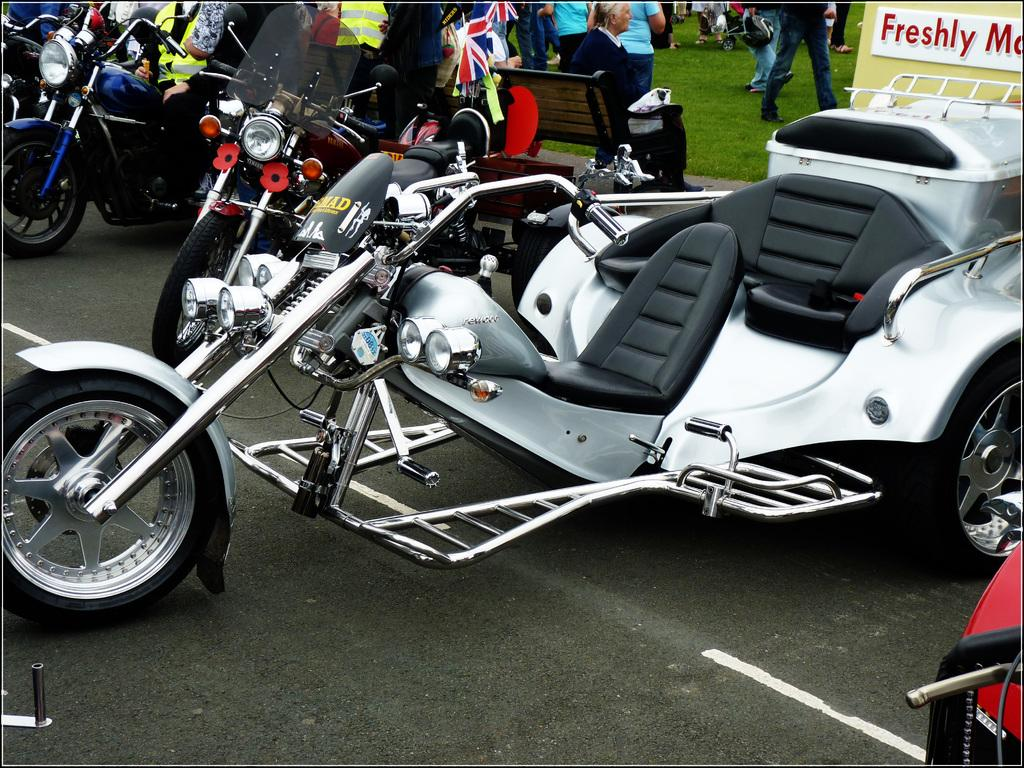Where is the location of the image? The image is outside of the city. What can be seen in the image besides the cityscape? There are many bikes in the image. Can you describe the people in the background? There is a woman sitting on a bench and a group of people walking on grass in the background. What type of stew is being served at the band's performance in the image? There is no band or stew present in the image. What type of vacation is the woman on, as depicted in the image? The image does not provide any information about the woman's vacation or any vacation-related activities. 